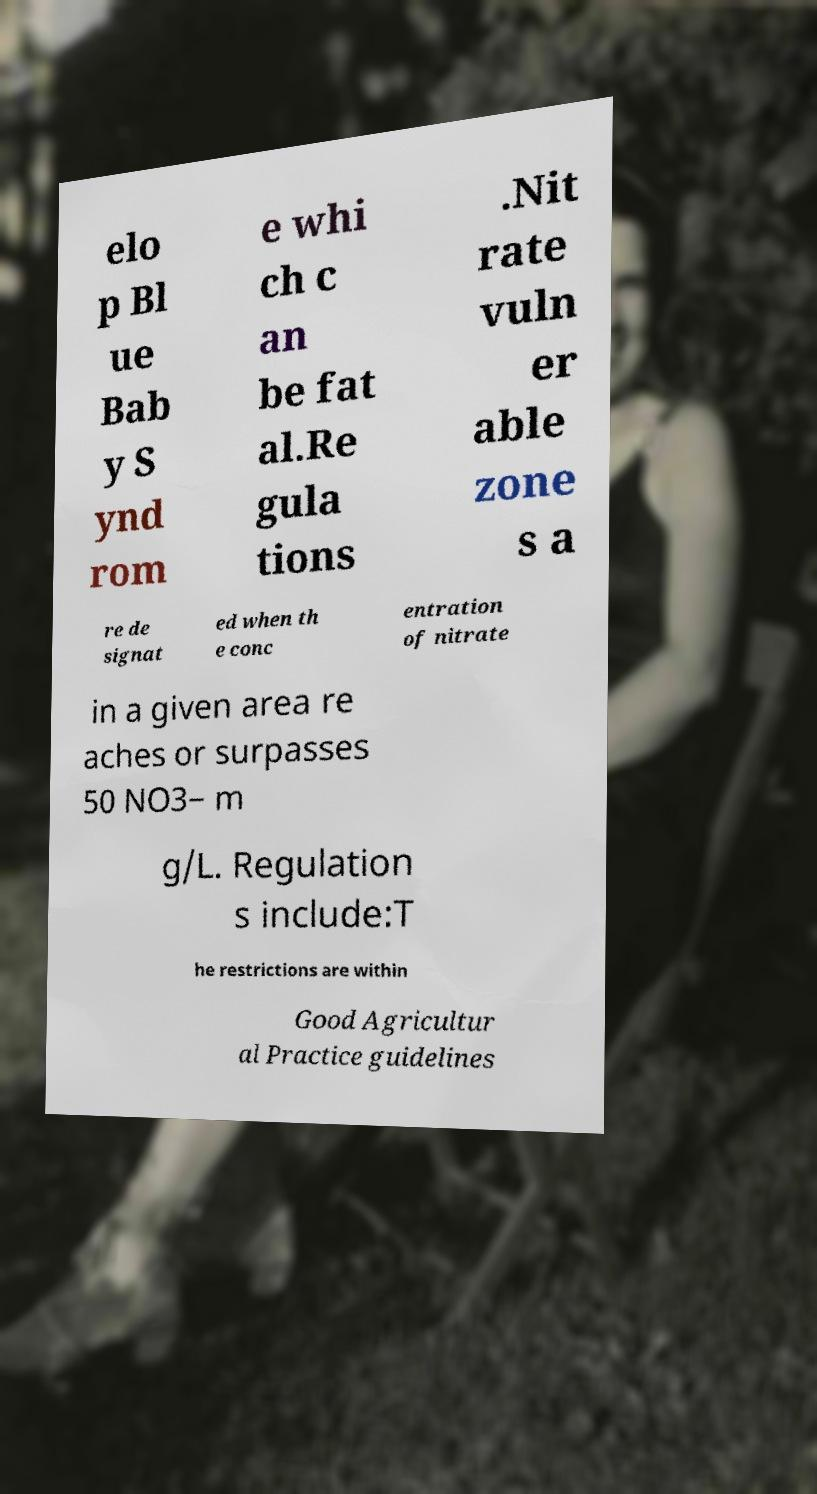For documentation purposes, I need the text within this image transcribed. Could you provide that? elo p Bl ue Bab y S ynd rom e whi ch c an be fat al.Re gula tions .Nit rate vuln er able zone s a re de signat ed when th e conc entration of nitrate in a given area re aches or surpasses 50 NO3− m g/L. Regulation s include:T he restrictions are within Good Agricultur al Practice guidelines 